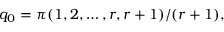<formula> <loc_0><loc_0><loc_500><loc_500>q _ { 0 } = \pi ( 1 , 2 , \dots , r , r + 1 ) / ( r + 1 ) ,</formula> 